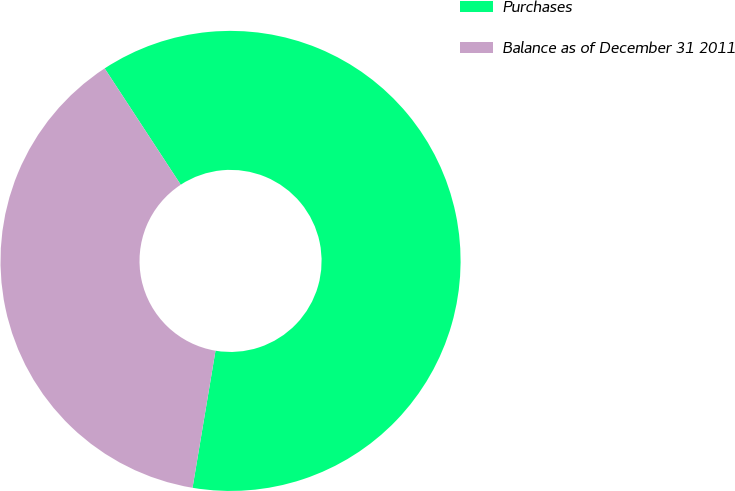Convert chart to OTSL. <chart><loc_0><loc_0><loc_500><loc_500><pie_chart><fcel>Purchases<fcel>Balance as of December 31 2011<nl><fcel>61.86%<fcel>38.14%<nl></chart> 